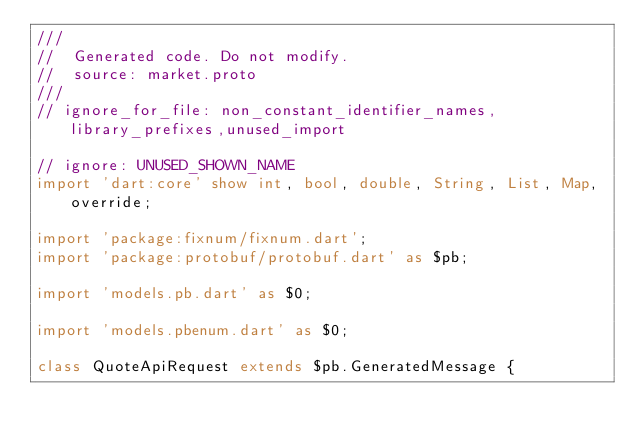<code> <loc_0><loc_0><loc_500><loc_500><_Dart_>///
//  Generated code. Do not modify.
//  source: market.proto
///
// ignore_for_file: non_constant_identifier_names,library_prefixes,unused_import

// ignore: UNUSED_SHOWN_NAME
import 'dart:core' show int, bool, double, String, List, Map, override;

import 'package:fixnum/fixnum.dart';
import 'package:protobuf/protobuf.dart' as $pb;

import 'models.pb.dart' as $0;

import 'models.pbenum.dart' as $0;

class QuoteApiRequest extends $pb.GeneratedMessage {</code> 